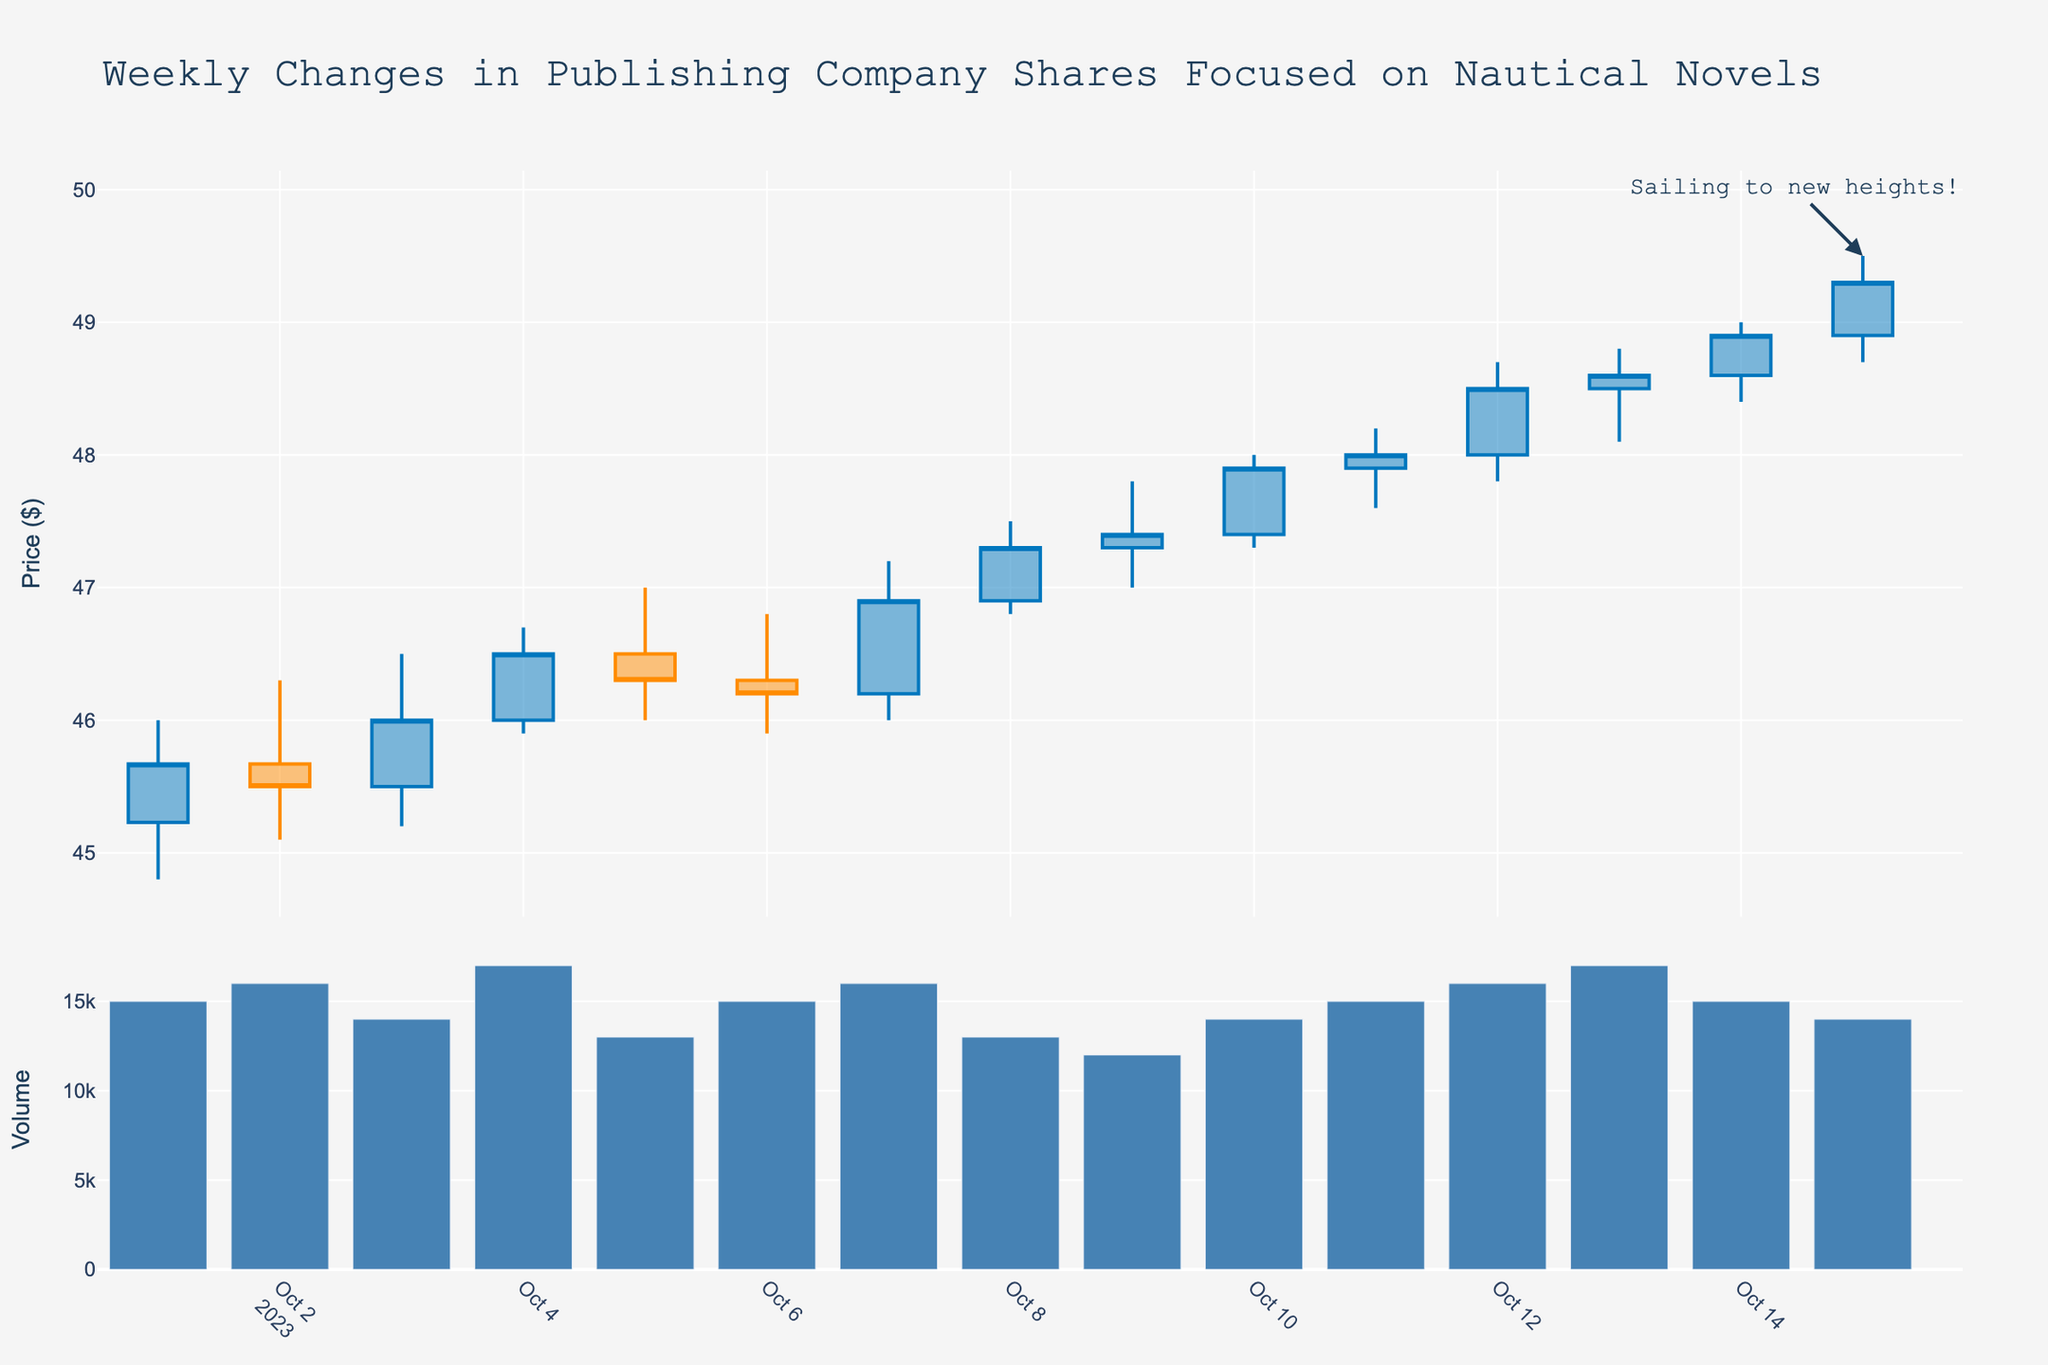What is the title of the figure? The title is usually displayed at the top of the chart, it summarizes the main content of the figure.
Answer: Weekly Changes in Publishing Company Shares Focused on Nautical Novels What are the dates for the first and last data points? The dates can be seen at the bottom of the x-axis. The first data point is at the start of the axis and the last is at the end.
Answer: 2023-10-01 to 2023-10-15 What does the blue-colored candlestick represent in the plot? The colors of the candlesticks indicate price movement. Blue likely represents days when the closing price was higher than the opening price.
Answer: An increase in price On which date did the stock price reach its highest value and what was that value? Look at the highest point of the candlestick wicks in the plot to find the max value and identify its corresponding date.
Answer: 2023-10-15, $49.50 What was the closing price on October 10th, 2023? The closing price on a specific date can be determined from the end caps of the candlestick for that day.
Answer: $47.90 What is the average trading volume over the period shown? Add all the trading volumes and divide by the number of days. (15000+16000+14000+17000+13000+15000+16000+13000+12000+14000+15000+16000+17000+15000+14000)/15 = 147000/15 = 9800
Answer: 9800 Compare the highest trading volumes between the first and second half of the dataset. Which half had the higher maximum volume and what are those values? The first half is from October 1st to 7th and the second half is from October 8th to 15th. Identify the maximum volumes in each period and compare them. Max of first half = 17000, max of second half = 17000. Both are equal.
Answer: Both are equal, 17000 On which date did the stock price decrease the most and by how much? Identify the dates where the opening price is higher than the closing price and find the maximum difference. The highest drop: Oct 5th, where (46.50 - 46.30) = 0.20.
Answer: October 5, $0.20 When did the stock close at exactly $48.00? Look at the end of the candlestick that precisely lines up with $48.00 on the y-axis and note the corresponding date.
Answer: October 11 Which day saw the highest swing (difference between high and low prices), and what was the value of that swing? Look for the candlestick with the longest wicks from top to bottom and calculate the difference between the high and low prices for that day. The highest swing is $1.20 on October 14, calculated as 49.00 - 47.80.
Answer: October 14, $1.20 